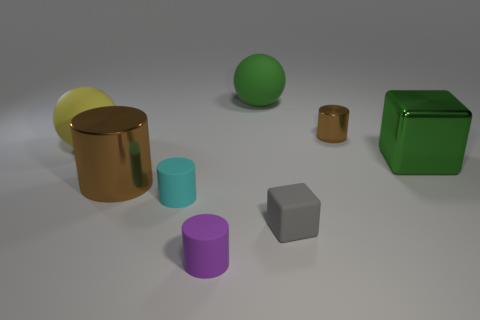Add 1 cubes. How many objects exist? 9 Subtract all spheres. How many objects are left? 6 Add 2 red rubber objects. How many red rubber objects exist? 2 Subtract 0 purple cubes. How many objects are left? 8 Subtract all cyan spheres. Subtract all cyan objects. How many objects are left? 7 Add 7 green shiny objects. How many green shiny objects are left? 8 